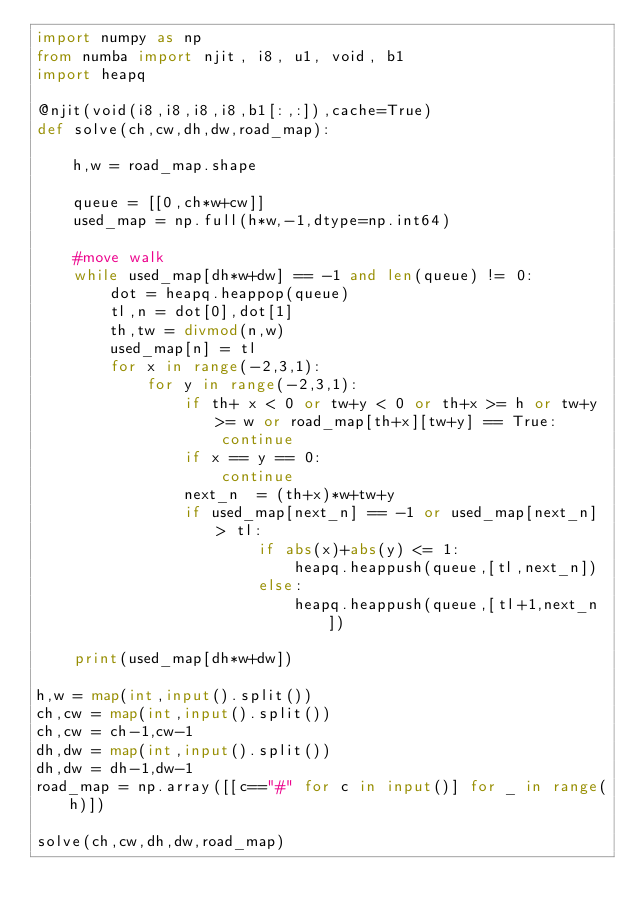<code> <loc_0><loc_0><loc_500><loc_500><_Python_>import numpy as np
from numba import njit, i8, u1, void, b1
import heapq

@njit(void(i8,i8,i8,i8,b1[:,:]),cache=True)
def solve(ch,cw,dh,dw,road_map):

    h,w = road_map.shape

    queue = [[0,ch*w+cw]]
    used_map = np.full(h*w,-1,dtype=np.int64)

    #move walk
    while used_map[dh*w+dw] == -1 and len(queue) != 0:
        dot = heapq.heappop(queue)
        tl,n = dot[0],dot[1]
        th,tw = divmod(n,w)
        used_map[n] = tl
        for x in range(-2,3,1):
            for y in range(-2,3,1):
                if th+ x < 0 or tw+y < 0 or th+x >= h or tw+y >= w or road_map[th+x][tw+y] == True:
                    continue
                if x == y == 0:
                    continue
                next_n  = (th+x)*w+tw+y
                if used_map[next_n] == -1 or used_map[next_n] > tl:
                        if abs(x)+abs(y) <= 1:
                            heapq.heappush(queue,[tl,next_n])
                        else:
                            heapq.heappush(queue,[tl+1,next_n])

    print(used_map[dh*w+dw])

h,w = map(int,input().split())
ch,cw = map(int,input().split())
ch,cw = ch-1,cw-1
dh,dw = map(int,input().split())
dh,dw = dh-1,dw-1
road_map = np.array([[c=="#" for c in input()] for _ in range(h)])

solve(ch,cw,dh,dw,road_map)

</code> 